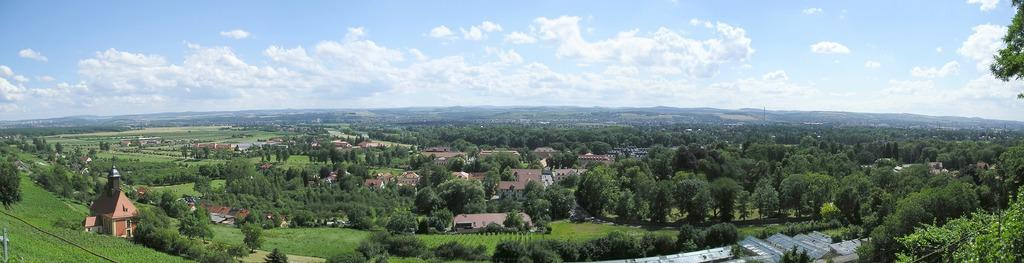What type of vegetation is present in the image? There are trees in the image. What type of structures can be seen in the image? There are buildings in the image. What type of ground cover is visible in the image? There is grass in the image. What type of substance is being used to clean the chicken in the image? There is no chicken or cleaning substance present in the image. Where is the spot on the ground in the image? There is no spot on the ground in the image. 